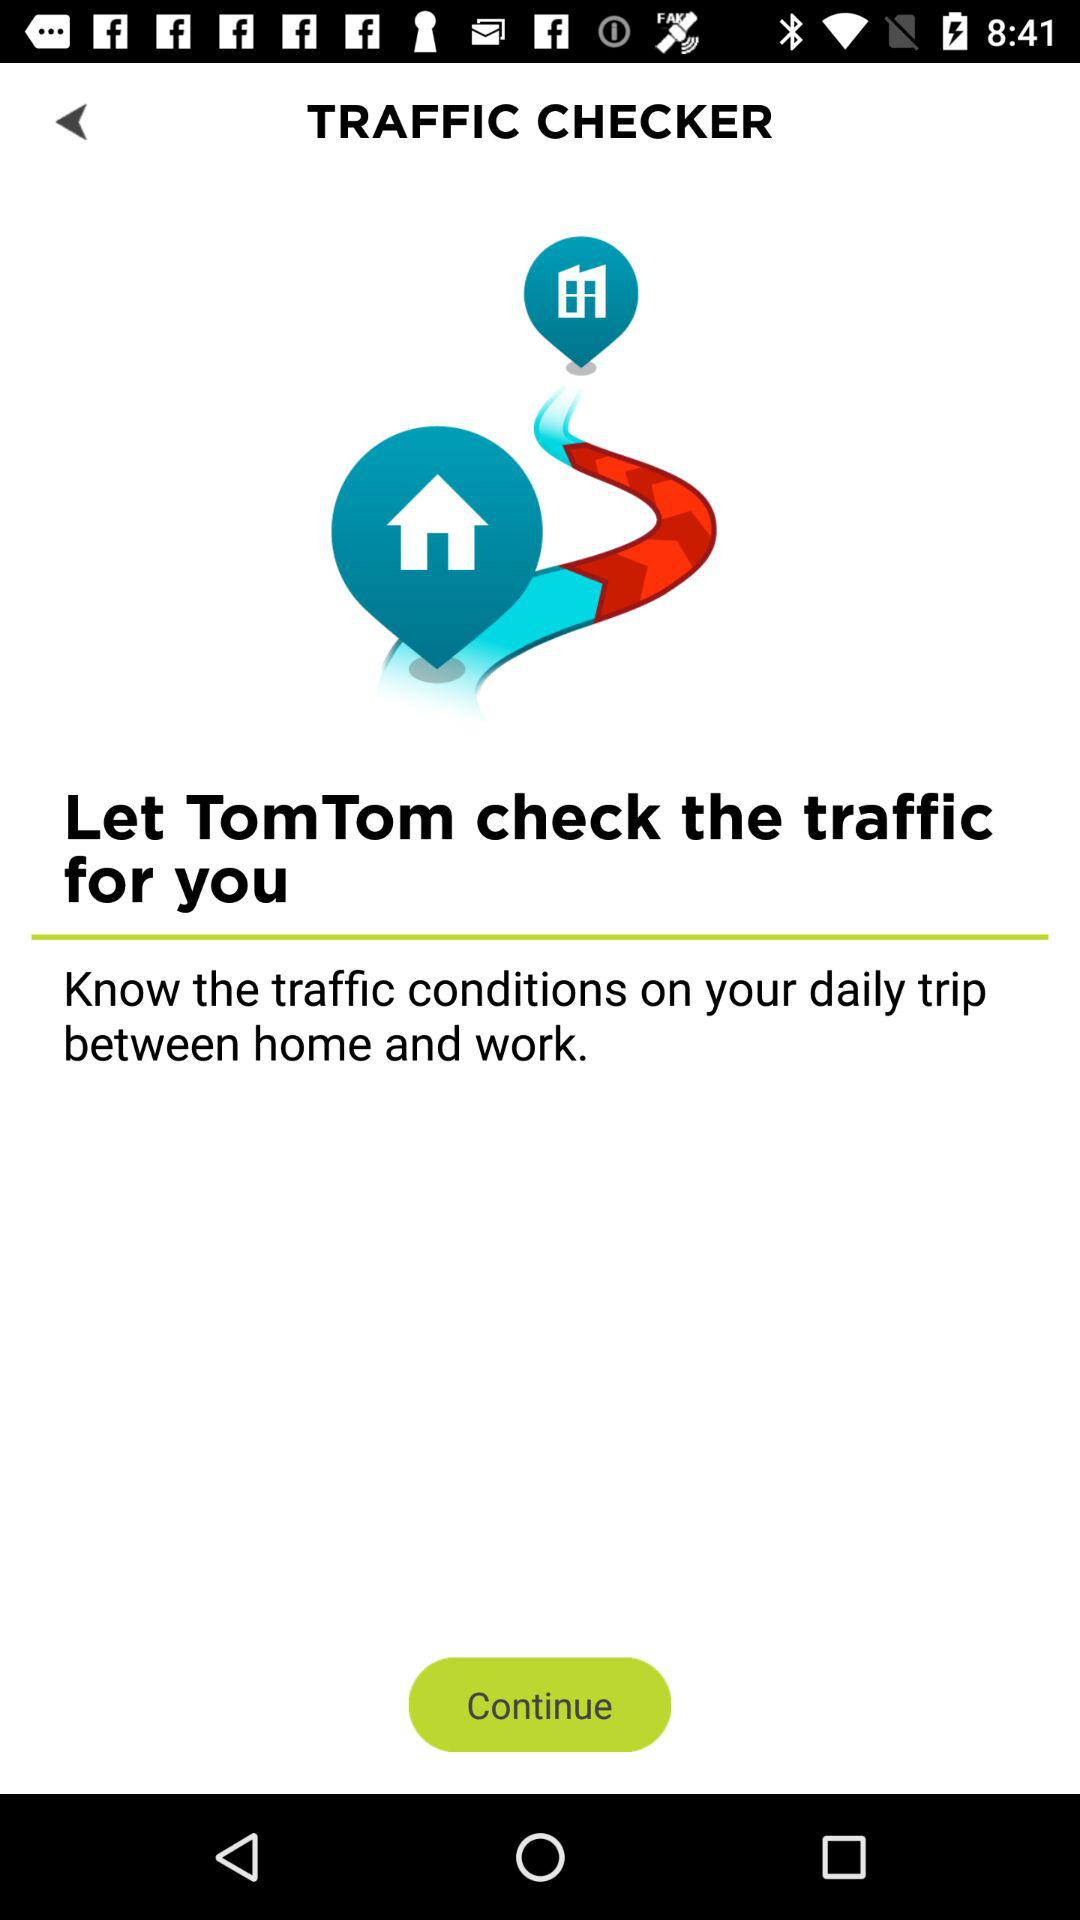What is the application name? The application name is "TRAFFIC CHECKER". 